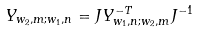Convert formula to latex. <formula><loc_0><loc_0><loc_500><loc_500>Y _ { w _ { 2 } , m ; w _ { 1 } , n } = J Y ^ { - T } _ { w _ { 1 } , n ; w _ { 2 } , m } J ^ { - 1 }</formula> 